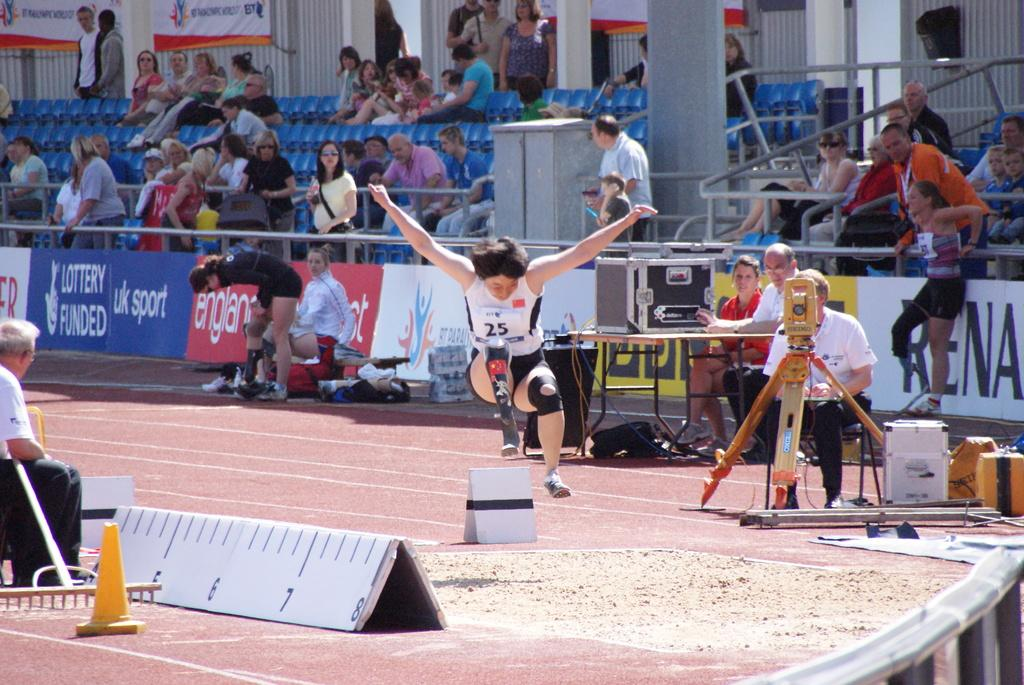<image>
Present a compact description of the photo's key features. Woman wearing number 25 competing in a competition. 